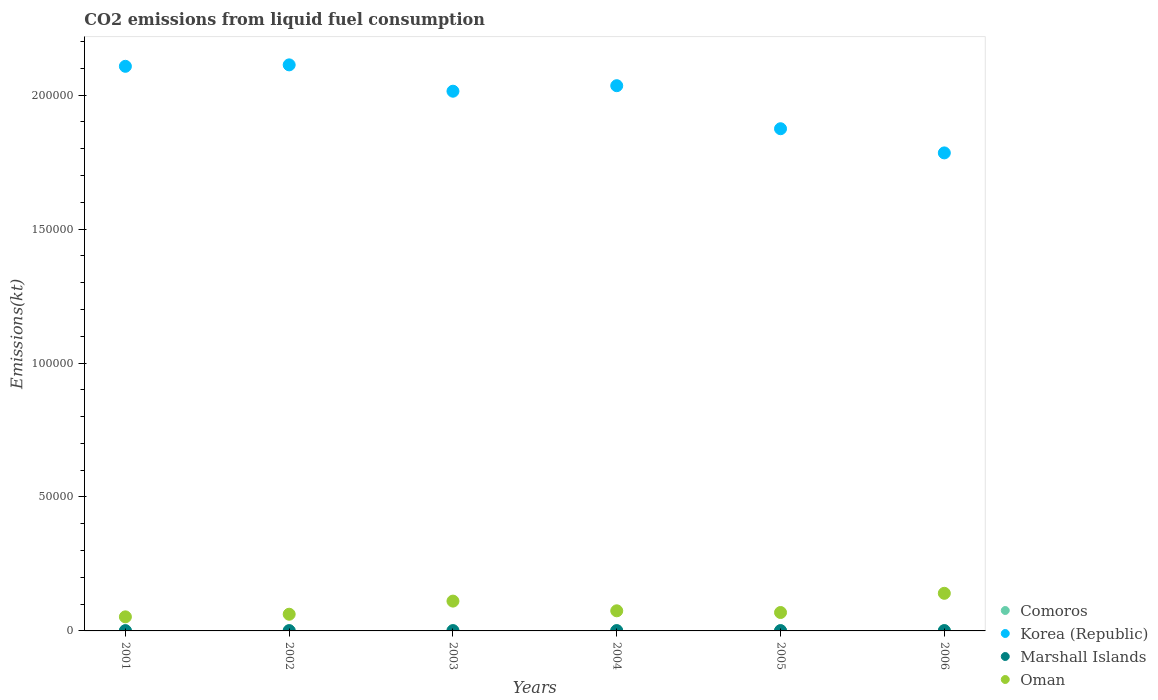How many different coloured dotlines are there?
Provide a short and direct response. 4. Is the number of dotlines equal to the number of legend labels?
Provide a succinct answer. Yes. What is the amount of CO2 emitted in Comoros in 2001?
Make the answer very short. 88.01. Across all years, what is the maximum amount of CO2 emitted in Korea (Republic)?
Your response must be concise. 2.11e+05. Across all years, what is the minimum amount of CO2 emitted in Oman?
Offer a terse response. 5254.81. In which year was the amount of CO2 emitted in Comoros minimum?
Make the answer very short. 2001. What is the total amount of CO2 emitted in Comoros in the graph?
Your response must be concise. 612.39. What is the difference between the amount of CO2 emitted in Comoros in 2002 and that in 2006?
Ensure brevity in your answer.  -29.34. What is the difference between the amount of CO2 emitted in Korea (Republic) in 2004 and the amount of CO2 emitted in Marshall Islands in 2001?
Ensure brevity in your answer.  2.03e+05. What is the average amount of CO2 emitted in Comoros per year?
Offer a terse response. 102.06. In the year 2004, what is the difference between the amount of CO2 emitted in Korea (Republic) and amount of CO2 emitted in Comoros?
Ensure brevity in your answer.  2.03e+05. What is the ratio of the amount of CO2 emitted in Oman in 2002 to that in 2006?
Your answer should be very brief. 0.44. Is the amount of CO2 emitted in Korea (Republic) in 2001 less than that in 2004?
Your answer should be compact. No. What is the difference between the highest and the second highest amount of CO2 emitted in Korea (Republic)?
Keep it short and to the point. 539.05. What is the difference between the highest and the lowest amount of CO2 emitted in Comoros?
Your answer should be compact. 33. In how many years, is the amount of CO2 emitted in Korea (Republic) greater than the average amount of CO2 emitted in Korea (Republic) taken over all years?
Provide a short and direct response. 4. Is it the case that in every year, the sum of the amount of CO2 emitted in Marshall Islands and amount of CO2 emitted in Korea (Republic)  is greater than the amount of CO2 emitted in Oman?
Your answer should be very brief. Yes. Does the amount of CO2 emitted in Korea (Republic) monotonically increase over the years?
Your response must be concise. No. Is the amount of CO2 emitted in Comoros strictly greater than the amount of CO2 emitted in Oman over the years?
Offer a terse response. No. How many dotlines are there?
Ensure brevity in your answer.  4. What is the title of the graph?
Offer a very short reply. CO2 emissions from liquid fuel consumption. Does "Swaziland" appear as one of the legend labels in the graph?
Provide a short and direct response. No. What is the label or title of the Y-axis?
Ensure brevity in your answer.  Emissions(kt). What is the Emissions(kt) of Comoros in 2001?
Offer a terse response. 88.01. What is the Emissions(kt) of Korea (Republic) in 2001?
Offer a very short reply. 2.11e+05. What is the Emissions(kt) of Marshall Islands in 2001?
Your answer should be compact. 80.67. What is the Emissions(kt) in Oman in 2001?
Your response must be concise. 5254.81. What is the Emissions(kt) in Comoros in 2002?
Your response must be concise. 91.67. What is the Emissions(kt) of Korea (Republic) in 2002?
Provide a succinct answer. 2.11e+05. What is the Emissions(kt) of Marshall Islands in 2002?
Your response must be concise. 84.34. What is the Emissions(kt) in Oman in 2002?
Ensure brevity in your answer.  6230.23. What is the Emissions(kt) in Comoros in 2003?
Provide a short and direct response. 99.01. What is the Emissions(kt) in Korea (Republic) in 2003?
Offer a very short reply. 2.01e+05. What is the Emissions(kt) in Marshall Islands in 2003?
Give a very brief answer. 84.34. What is the Emissions(kt) of Oman in 2003?
Ensure brevity in your answer.  1.11e+04. What is the Emissions(kt) of Comoros in 2004?
Make the answer very short. 102.68. What is the Emissions(kt) in Korea (Republic) in 2004?
Provide a short and direct response. 2.04e+05. What is the Emissions(kt) of Marshall Islands in 2004?
Make the answer very short. 88.01. What is the Emissions(kt) in Oman in 2004?
Keep it short and to the point. 7510.02. What is the Emissions(kt) of Comoros in 2005?
Provide a short and direct response. 110.01. What is the Emissions(kt) in Korea (Republic) in 2005?
Offer a terse response. 1.87e+05. What is the Emissions(kt) in Marshall Islands in 2005?
Offer a very short reply. 84.34. What is the Emissions(kt) in Oman in 2005?
Ensure brevity in your answer.  6875.62. What is the Emissions(kt) of Comoros in 2006?
Provide a short and direct response. 121.01. What is the Emissions(kt) of Korea (Republic) in 2006?
Make the answer very short. 1.78e+05. What is the Emissions(kt) in Marshall Islands in 2006?
Your answer should be very brief. 91.67. What is the Emissions(kt) of Oman in 2006?
Provide a succinct answer. 1.40e+04. Across all years, what is the maximum Emissions(kt) of Comoros?
Your response must be concise. 121.01. Across all years, what is the maximum Emissions(kt) of Korea (Republic)?
Your response must be concise. 2.11e+05. Across all years, what is the maximum Emissions(kt) of Marshall Islands?
Offer a terse response. 91.67. Across all years, what is the maximum Emissions(kt) in Oman?
Provide a succinct answer. 1.40e+04. Across all years, what is the minimum Emissions(kt) of Comoros?
Keep it short and to the point. 88.01. Across all years, what is the minimum Emissions(kt) in Korea (Republic)?
Offer a very short reply. 1.78e+05. Across all years, what is the minimum Emissions(kt) in Marshall Islands?
Your response must be concise. 80.67. Across all years, what is the minimum Emissions(kt) of Oman?
Offer a very short reply. 5254.81. What is the total Emissions(kt) of Comoros in the graph?
Offer a terse response. 612.39. What is the total Emissions(kt) in Korea (Republic) in the graph?
Provide a short and direct response. 1.19e+06. What is the total Emissions(kt) in Marshall Islands in the graph?
Offer a very short reply. 513.38. What is the total Emissions(kt) of Oman in the graph?
Provide a succinct answer. 5.10e+04. What is the difference between the Emissions(kt) in Comoros in 2001 and that in 2002?
Ensure brevity in your answer.  -3.67. What is the difference between the Emissions(kt) in Korea (Republic) in 2001 and that in 2002?
Offer a very short reply. -539.05. What is the difference between the Emissions(kt) in Marshall Islands in 2001 and that in 2002?
Give a very brief answer. -3.67. What is the difference between the Emissions(kt) in Oman in 2001 and that in 2002?
Keep it short and to the point. -975.42. What is the difference between the Emissions(kt) of Comoros in 2001 and that in 2003?
Provide a short and direct response. -11. What is the difference between the Emissions(kt) in Korea (Republic) in 2001 and that in 2003?
Your answer should be compact. 9295.84. What is the difference between the Emissions(kt) of Marshall Islands in 2001 and that in 2003?
Provide a short and direct response. -3.67. What is the difference between the Emissions(kt) of Oman in 2001 and that in 2003?
Your answer should be compact. -5874.53. What is the difference between the Emissions(kt) in Comoros in 2001 and that in 2004?
Offer a terse response. -14.67. What is the difference between the Emissions(kt) in Korea (Republic) in 2001 and that in 2004?
Your answer should be very brief. 7234.99. What is the difference between the Emissions(kt) in Marshall Islands in 2001 and that in 2004?
Your answer should be compact. -7.33. What is the difference between the Emissions(kt) of Oman in 2001 and that in 2004?
Your answer should be compact. -2255.2. What is the difference between the Emissions(kt) in Comoros in 2001 and that in 2005?
Ensure brevity in your answer.  -22. What is the difference between the Emissions(kt) in Korea (Republic) in 2001 and that in 2005?
Provide a short and direct response. 2.33e+04. What is the difference between the Emissions(kt) of Marshall Islands in 2001 and that in 2005?
Keep it short and to the point. -3.67. What is the difference between the Emissions(kt) of Oman in 2001 and that in 2005?
Your answer should be very brief. -1620.81. What is the difference between the Emissions(kt) of Comoros in 2001 and that in 2006?
Ensure brevity in your answer.  -33. What is the difference between the Emissions(kt) of Korea (Republic) in 2001 and that in 2006?
Your response must be concise. 3.23e+04. What is the difference between the Emissions(kt) of Marshall Islands in 2001 and that in 2006?
Provide a succinct answer. -11. What is the difference between the Emissions(kt) of Oman in 2001 and that in 2006?
Ensure brevity in your answer.  -8786.13. What is the difference between the Emissions(kt) of Comoros in 2002 and that in 2003?
Your answer should be very brief. -7.33. What is the difference between the Emissions(kt) in Korea (Republic) in 2002 and that in 2003?
Your response must be concise. 9834.89. What is the difference between the Emissions(kt) of Marshall Islands in 2002 and that in 2003?
Offer a terse response. 0. What is the difference between the Emissions(kt) of Oman in 2002 and that in 2003?
Keep it short and to the point. -4899.11. What is the difference between the Emissions(kt) of Comoros in 2002 and that in 2004?
Your answer should be very brief. -11. What is the difference between the Emissions(kt) in Korea (Republic) in 2002 and that in 2004?
Ensure brevity in your answer.  7774.04. What is the difference between the Emissions(kt) of Marshall Islands in 2002 and that in 2004?
Keep it short and to the point. -3.67. What is the difference between the Emissions(kt) of Oman in 2002 and that in 2004?
Make the answer very short. -1279.78. What is the difference between the Emissions(kt) in Comoros in 2002 and that in 2005?
Provide a succinct answer. -18.34. What is the difference between the Emissions(kt) in Korea (Republic) in 2002 and that in 2005?
Your answer should be very brief. 2.38e+04. What is the difference between the Emissions(kt) of Oman in 2002 and that in 2005?
Your answer should be very brief. -645.39. What is the difference between the Emissions(kt) in Comoros in 2002 and that in 2006?
Your answer should be very brief. -29.34. What is the difference between the Emissions(kt) of Korea (Republic) in 2002 and that in 2006?
Your answer should be very brief. 3.29e+04. What is the difference between the Emissions(kt) of Marshall Islands in 2002 and that in 2006?
Your answer should be compact. -7.33. What is the difference between the Emissions(kt) in Oman in 2002 and that in 2006?
Provide a short and direct response. -7810.71. What is the difference between the Emissions(kt) of Comoros in 2003 and that in 2004?
Keep it short and to the point. -3.67. What is the difference between the Emissions(kt) in Korea (Republic) in 2003 and that in 2004?
Offer a terse response. -2060.85. What is the difference between the Emissions(kt) in Marshall Islands in 2003 and that in 2004?
Ensure brevity in your answer.  -3.67. What is the difference between the Emissions(kt) in Oman in 2003 and that in 2004?
Provide a short and direct response. 3619.33. What is the difference between the Emissions(kt) in Comoros in 2003 and that in 2005?
Make the answer very short. -11. What is the difference between the Emissions(kt) of Korea (Republic) in 2003 and that in 2005?
Give a very brief answer. 1.40e+04. What is the difference between the Emissions(kt) in Oman in 2003 and that in 2005?
Ensure brevity in your answer.  4253.72. What is the difference between the Emissions(kt) in Comoros in 2003 and that in 2006?
Provide a short and direct response. -22. What is the difference between the Emissions(kt) of Korea (Republic) in 2003 and that in 2006?
Provide a succinct answer. 2.30e+04. What is the difference between the Emissions(kt) of Marshall Islands in 2003 and that in 2006?
Ensure brevity in your answer.  -7.33. What is the difference between the Emissions(kt) of Oman in 2003 and that in 2006?
Keep it short and to the point. -2911.6. What is the difference between the Emissions(kt) of Comoros in 2004 and that in 2005?
Provide a short and direct response. -7.33. What is the difference between the Emissions(kt) of Korea (Republic) in 2004 and that in 2005?
Your answer should be very brief. 1.61e+04. What is the difference between the Emissions(kt) of Marshall Islands in 2004 and that in 2005?
Provide a short and direct response. 3.67. What is the difference between the Emissions(kt) of Oman in 2004 and that in 2005?
Make the answer very short. 634.39. What is the difference between the Emissions(kt) of Comoros in 2004 and that in 2006?
Provide a short and direct response. -18.34. What is the difference between the Emissions(kt) of Korea (Republic) in 2004 and that in 2006?
Make the answer very short. 2.51e+04. What is the difference between the Emissions(kt) of Marshall Islands in 2004 and that in 2006?
Keep it short and to the point. -3.67. What is the difference between the Emissions(kt) of Oman in 2004 and that in 2006?
Your response must be concise. -6530.93. What is the difference between the Emissions(kt) of Comoros in 2005 and that in 2006?
Offer a very short reply. -11. What is the difference between the Emissions(kt) in Korea (Republic) in 2005 and that in 2006?
Your answer should be very brief. 9024.49. What is the difference between the Emissions(kt) in Marshall Islands in 2005 and that in 2006?
Offer a terse response. -7.33. What is the difference between the Emissions(kt) in Oman in 2005 and that in 2006?
Offer a terse response. -7165.32. What is the difference between the Emissions(kt) in Comoros in 2001 and the Emissions(kt) in Korea (Republic) in 2002?
Your response must be concise. -2.11e+05. What is the difference between the Emissions(kt) in Comoros in 2001 and the Emissions(kt) in Marshall Islands in 2002?
Offer a terse response. 3.67. What is the difference between the Emissions(kt) of Comoros in 2001 and the Emissions(kt) of Oman in 2002?
Keep it short and to the point. -6142.23. What is the difference between the Emissions(kt) in Korea (Republic) in 2001 and the Emissions(kt) in Marshall Islands in 2002?
Make the answer very short. 2.11e+05. What is the difference between the Emissions(kt) in Korea (Republic) in 2001 and the Emissions(kt) in Oman in 2002?
Make the answer very short. 2.05e+05. What is the difference between the Emissions(kt) in Marshall Islands in 2001 and the Emissions(kt) in Oman in 2002?
Provide a succinct answer. -6149.56. What is the difference between the Emissions(kt) in Comoros in 2001 and the Emissions(kt) in Korea (Republic) in 2003?
Your answer should be compact. -2.01e+05. What is the difference between the Emissions(kt) in Comoros in 2001 and the Emissions(kt) in Marshall Islands in 2003?
Your response must be concise. 3.67. What is the difference between the Emissions(kt) of Comoros in 2001 and the Emissions(kt) of Oman in 2003?
Keep it short and to the point. -1.10e+04. What is the difference between the Emissions(kt) of Korea (Republic) in 2001 and the Emissions(kt) of Marshall Islands in 2003?
Provide a succinct answer. 2.11e+05. What is the difference between the Emissions(kt) in Korea (Republic) in 2001 and the Emissions(kt) in Oman in 2003?
Offer a terse response. 2.00e+05. What is the difference between the Emissions(kt) of Marshall Islands in 2001 and the Emissions(kt) of Oman in 2003?
Keep it short and to the point. -1.10e+04. What is the difference between the Emissions(kt) in Comoros in 2001 and the Emissions(kt) in Korea (Republic) in 2004?
Provide a succinct answer. -2.03e+05. What is the difference between the Emissions(kt) in Comoros in 2001 and the Emissions(kt) in Oman in 2004?
Keep it short and to the point. -7422.01. What is the difference between the Emissions(kt) in Korea (Republic) in 2001 and the Emissions(kt) in Marshall Islands in 2004?
Your answer should be compact. 2.11e+05. What is the difference between the Emissions(kt) of Korea (Republic) in 2001 and the Emissions(kt) of Oman in 2004?
Offer a very short reply. 2.03e+05. What is the difference between the Emissions(kt) in Marshall Islands in 2001 and the Emissions(kt) in Oman in 2004?
Provide a short and direct response. -7429.34. What is the difference between the Emissions(kt) of Comoros in 2001 and the Emissions(kt) of Korea (Republic) in 2005?
Provide a succinct answer. -1.87e+05. What is the difference between the Emissions(kt) in Comoros in 2001 and the Emissions(kt) in Marshall Islands in 2005?
Your response must be concise. 3.67. What is the difference between the Emissions(kt) in Comoros in 2001 and the Emissions(kt) in Oman in 2005?
Ensure brevity in your answer.  -6787.62. What is the difference between the Emissions(kt) of Korea (Republic) in 2001 and the Emissions(kt) of Marshall Islands in 2005?
Your response must be concise. 2.11e+05. What is the difference between the Emissions(kt) in Korea (Republic) in 2001 and the Emissions(kt) in Oman in 2005?
Make the answer very short. 2.04e+05. What is the difference between the Emissions(kt) in Marshall Islands in 2001 and the Emissions(kt) in Oman in 2005?
Your response must be concise. -6794.95. What is the difference between the Emissions(kt) in Comoros in 2001 and the Emissions(kt) in Korea (Republic) in 2006?
Your answer should be very brief. -1.78e+05. What is the difference between the Emissions(kt) in Comoros in 2001 and the Emissions(kt) in Marshall Islands in 2006?
Provide a succinct answer. -3.67. What is the difference between the Emissions(kt) in Comoros in 2001 and the Emissions(kt) in Oman in 2006?
Ensure brevity in your answer.  -1.40e+04. What is the difference between the Emissions(kt) in Korea (Republic) in 2001 and the Emissions(kt) in Marshall Islands in 2006?
Provide a succinct answer. 2.11e+05. What is the difference between the Emissions(kt) in Korea (Republic) in 2001 and the Emissions(kt) in Oman in 2006?
Your response must be concise. 1.97e+05. What is the difference between the Emissions(kt) of Marshall Islands in 2001 and the Emissions(kt) of Oman in 2006?
Offer a very short reply. -1.40e+04. What is the difference between the Emissions(kt) in Comoros in 2002 and the Emissions(kt) in Korea (Republic) in 2003?
Offer a terse response. -2.01e+05. What is the difference between the Emissions(kt) of Comoros in 2002 and the Emissions(kt) of Marshall Islands in 2003?
Provide a succinct answer. 7.33. What is the difference between the Emissions(kt) of Comoros in 2002 and the Emissions(kt) of Oman in 2003?
Your answer should be very brief. -1.10e+04. What is the difference between the Emissions(kt) of Korea (Republic) in 2002 and the Emissions(kt) of Marshall Islands in 2003?
Provide a succinct answer. 2.11e+05. What is the difference between the Emissions(kt) in Korea (Republic) in 2002 and the Emissions(kt) in Oman in 2003?
Make the answer very short. 2.00e+05. What is the difference between the Emissions(kt) in Marshall Islands in 2002 and the Emissions(kt) in Oman in 2003?
Give a very brief answer. -1.10e+04. What is the difference between the Emissions(kt) in Comoros in 2002 and the Emissions(kt) in Korea (Republic) in 2004?
Give a very brief answer. -2.03e+05. What is the difference between the Emissions(kt) in Comoros in 2002 and the Emissions(kt) in Marshall Islands in 2004?
Your answer should be compact. 3.67. What is the difference between the Emissions(kt) in Comoros in 2002 and the Emissions(kt) in Oman in 2004?
Your answer should be very brief. -7418.34. What is the difference between the Emissions(kt) in Korea (Republic) in 2002 and the Emissions(kt) in Marshall Islands in 2004?
Offer a terse response. 2.11e+05. What is the difference between the Emissions(kt) of Korea (Republic) in 2002 and the Emissions(kt) of Oman in 2004?
Make the answer very short. 2.04e+05. What is the difference between the Emissions(kt) of Marshall Islands in 2002 and the Emissions(kt) of Oman in 2004?
Provide a short and direct response. -7425.68. What is the difference between the Emissions(kt) of Comoros in 2002 and the Emissions(kt) of Korea (Republic) in 2005?
Give a very brief answer. -1.87e+05. What is the difference between the Emissions(kt) of Comoros in 2002 and the Emissions(kt) of Marshall Islands in 2005?
Your answer should be very brief. 7.33. What is the difference between the Emissions(kt) of Comoros in 2002 and the Emissions(kt) of Oman in 2005?
Offer a terse response. -6783.95. What is the difference between the Emissions(kt) of Korea (Republic) in 2002 and the Emissions(kt) of Marshall Islands in 2005?
Provide a short and direct response. 2.11e+05. What is the difference between the Emissions(kt) in Korea (Republic) in 2002 and the Emissions(kt) in Oman in 2005?
Ensure brevity in your answer.  2.04e+05. What is the difference between the Emissions(kt) in Marshall Islands in 2002 and the Emissions(kt) in Oman in 2005?
Keep it short and to the point. -6791.28. What is the difference between the Emissions(kt) in Comoros in 2002 and the Emissions(kt) in Korea (Republic) in 2006?
Your answer should be compact. -1.78e+05. What is the difference between the Emissions(kt) in Comoros in 2002 and the Emissions(kt) in Marshall Islands in 2006?
Provide a succinct answer. 0. What is the difference between the Emissions(kt) in Comoros in 2002 and the Emissions(kt) in Oman in 2006?
Offer a very short reply. -1.39e+04. What is the difference between the Emissions(kt) in Korea (Republic) in 2002 and the Emissions(kt) in Marshall Islands in 2006?
Your answer should be compact. 2.11e+05. What is the difference between the Emissions(kt) of Korea (Republic) in 2002 and the Emissions(kt) of Oman in 2006?
Offer a terse response. 1.97e+05. What is the difference between the Emissions(kt) of Marshall Islands in 2002 and the Emissions(kt) of Oman in 2006?
Make the answer very short. -1.40e+04. What is the difference between the Emissions(kt) of Comoros in 2003 and the Emissions(kt) of Korea (Republic) in 2004?
Make the answer very short. -2.03e+05. What is the difference between the Emissions(kt) in Comoros in 2003 and the Emissions(kt) in Marshall Islands in 2004?
Offer a terse response. 11. What is the difference between the Emissions(kt) in Comoros in 2003 and the Emissions(kt) in Oman in 2004?
Your answer should be very brief. -7411.01. What is the difference between the Emissions(kt) in Korea (Republic) in 2003 and the Emissions(kt) in Marshall Islands in 2004?
Offer a terse response. 2.01e+05. What is the difference between the Emissions(kt) in Korea (Republic) in 2003 and the Emissions(kt) in Oman in 2004?
Offer a very short reply. 1.94e+05. What is the difference between the Emissions(kt) of Marshall Islands in 2003 and the Emissions(kt) of Oman in 2004?
Keep it short and to the point. -7425.68. What is the difference between the Emissions(kt) in Comoros in 2003 and the Emissions(kt) in Korea (Republic) in 2005?
Keep it short and to the point. -1.87e+05. What is the difference between the Emissions(kt) of Comoros in 2003 and the Emissions(kt) of Marshall Islands in 2005?
Provide a short and direct response. 14.67. What is the difference between the Emissions(kt) of Comoros in 2003 and the Emissions(kt) of Oman in 2005?
Offer a very short reply. -6776.62. What is the difference between the Emissions(kt) in Korea (Republic) in 2003 and the Emissions(kt) in Marshall Islands in 2005?
Provide a succinct answer. 2.01e+05. What is the difference between the Emissions(kt) of Korea (Republic) in 2003 and the Emissions(kt) of Oman in 2005?
Your response must be concise. 1.95e+05. What is the difference between the Emissions(kt) of Marshall Islands in 2003 and the Emissions(kt) of Oman in 2005?
Your answer should be very brief. -6791.28. What is the difference between the Emissions(kt) of Comoros in 2003 and the Emissions(kt) of Korea (Republic) in 2006?
Provide a succinct answer. -1.78e+05. What is the difference between the Emissions(kt) of Comoros in 2003 and the Emissions(kt) of Marshall Islands in 2006?
Provide a short and direct response. 7.33. What is the difference between the Emissions(kt) in Comoros in 2003 and the Emissions(kt) in Oman in 2006?
Your response must be concise. -1.39e+04. What is the difference between the Emissions(kt) of Korea (Republic) in 2003 and the Emissions(kt) of Marshall Islands in 2006?
Ensure brevity in your answer.  2.01e+05. What is the difference between the Emissions(kt) in Korea (Republic) in 2003 and the Emissions(kt) in Oman in 2006?
Give a very brief answer. 1.87e+05. What is the difference between the Emissions(kt) of Marshall Islands in 2003 and the Emissions(kt) of Oman in 2006?
Ensure brevity in your answer.  -1.40e+04. What is the difference between the Emissions(kt) of Comoros in 2004 and the Emissions(kt) of Korea (Republic) in 2005?
Ensure brevity in your answer.  -1.87e+05. What is the difference between the Emissions(kt) in Comoros in 2004 and the Emissions(kt) in Marshall Islands in 2005?
Ensure brevity in your answer.  18.34. What is the difference between the Emissions(kt) in Comoros in 2004 and the Emissions(kt) in Oman in 2005?
Provide a succinct answer. -6772.95. What is the difference between the Emissions(kt) of Korea (Republic) in 2004 and the Emissions(kt) of Marshall Islands in 2005?
Your answer should be very brief. 2.03e+05. What is the difference between the Emissions(kt) in Korea (Republic) in 2004 and the Emissions(kt) in Oman in 2005?
Provide a succinct answer. 1.97e+05. What is the difference between the Emissions(kt) of Marshall Islands in 2004 and the Emissions(kt) of Oman in 2005?
Make the answer very short. -6787.62. What is the difference between the Emissions(kt) of Comoros in 2004 and the Emissions(kt) of Korea (Republic) in 2006?
Provide a succinct answer. -1.78e+05. What is the difference between the Emissions(kt) of Comoros in 2004 and the Emissions(kt) of Marshall Islands in 2006?
Provide a succinct answer. 11. What is the difference between the Emissions(kt) of Comoros in 2004 and the Emissions(kt) of Oman in 2006?
Your answer should be very brief. -1.39e+04. What is the difference between the Emissions(kt) of Korea (Republic) in 2004 and the Emissions(kt) of Marshall Islands in 2006?
Offer a very short reply. 2.03e+05. What is the difference between the Emissions(kt) in Korea (Republic) in 2004 and the Emissions(kt) in Oman in 2006?
Make the answer very short. 1.90e+05. What is the difference between the Emissions(kt) of Marshall Islands in 2004 and the Emissions(kt) of Oman in 2006?
Offer a terse response. -1.40e+04. What is the difference between the Emissions(kt) in Comoros in 2005 and the Emissions(kt) in Korea (Republic) in 2006?
Offer a very short reply. -1.78e+05. What is the difference between the Emissions(kt) of Comoros in 2005 and the Emissions(kt) of Marshall Islands in 2006?
Offer a very short reply. 18.34. What is the difference between the Emissions(kt) of Comoros in 2005 and the Emissions(kt) of Oman in 2006?
Provide a short and direct response. -1.39e+04. What is the difference between the Emissions(kt) of Korea (Republic) in 2005 and the Emissions(kt) of Marshall Islands in 2006?
Provide a short and direct response. 1.87e+05. What is the difference between the Emissions(kt) of Korea (Republic) in 2005 and the Emissions(kt) of Oman in 2006?
Offer a very short reply. 1.73e+05. What is the difference between the Emissions(kt) in Marshall Islands in 2005 and the Emissions(kt) in Oman in 2006?
Ensure brevity in your answer.  -1.40e+04. What is the average Emissions(kt) in Comoros per year?
Give a very brief answer. 102.06. What is the average Emissions(kt) in Korea (Republic) per year?
Give a very brief answer. 1.99e+05. What is the average Emissions(kt) of Marshall Islands per year?
Your answer should be compact. 85.56. What is the average Emissions(kt) in Oman per year?
Your answer should be compact. 8506.83. In the year 2001, what is the difference between the Emissions(kt) of Comoros and Emissions(kt) of Korea (Republic)?
Your response must be concise. -2.11e+05. In the year 2001, what is the difference between the Emissions(kt) of Comoros and Emissions(kt) of Marshall Islands?
Provide a succinct answer. 7.33. In the year 2001, what is the difference between the Emissions(kt) in Comoros and Emissions(kt) in Oman?
Keep it short and to the point. -5166.8. In the year 2001, what is the difference between the Emissions(kt) in Korea (Republic) and Emissions(kt) in Marshall Islands?
Provide a succinct answer. 2.11e+05. In the year 2001, what is the difference between the Emissions(kt) in Korea (Republic) and Emissions(kt) in Oman?
Your answer should be compact. 2.06e+05. In the year 2001, what is the difference between the Emissions(kt) in Marshall Islands and Emissions(kt) in Oman?
Your answer should be compact. -5174.14. In the year 2002, what is the difference between the Emissions(kt) in Comoros and Emissions(kt) in Korea (Republic)?
Keep it short and to the point. -2.11e+05. In the year 2002, what is the difference between the Emissions(kt) in Comoros and Emissions(kt) in Marshall Islands?
Your answer should be very brief. 7.33. In the year 2002, what is the difference between the Emissions(kt) in Comoros and Emissions(kt) in Oman?
Offer a very short reply. -6138.56. In the year 2002, what is the difference between the Emissions(kt) in Korea (Republic) and Emissions(kt) in Marshall Islands?
Ensure brevity in your answer.  2.11e+05. In the year 2002, what is the difference between the Emissions(kt) of Korea (Republic) and Emissions(kt) of Oman?
Ensure brevity in your answer.  2.05e+05. In the year 2002, what is the difference between the Emissions(kt) of Marshall Islands and Emissions(kt) of Oman?
Offer a very short reply. -6145.89. In the year 2003, what is the difference between the Emissions(kt) of Comoros and Emissions(kt) of Korea (Republic)?
Provide a short and direct response. -2.01e+05. In the year 2003, what is the difference between the Emissions(kt) of Comoros and Emissions(kt) of Marshall Islands?
Ensure brevity in your answer.  14.67. In the year 2003, what is the difference between the Emissions(kt) of Comoros and Emissions(kt) of Oman?
Your answer should be compact. -1.10e+04. In the year 2003, what is the difference between the Emissions(kt) in Korea (Republic) and Emissions(kt) in Marshall Islands?
Offer a very short reply. 2.01e+05. In the year 2003, what is the difference between the Emissions(kt) of Korea (Republic) and Emissions(kt) of Oman?
Offer a very short reply. 1.90e+05. In the year 2003, what is the difference between the Emissions(kt) in Marshall Islands and Emissions(kt) in Oman?
Make the answer very short. -1.10e+04. In the year 2004, what is the difference between the Emissions(kt) in Comoros and Emissions(kt) in Korea (Republic)?
Keep it short and to the point. -2.03e+05. In the year 2004, what is the difference between the Emissions(kt) in Comoros and Emissions(kt) in Marshall Islands?
Give a very brief answer. 14.67. In the year 2004, what is the difference between the Emissions(kt) in Comoros and Emissions(kt) in Oman?
Make the answer very short. -7407.34. In the year 2004, what is the difference between the Emissions(kt) of Korea (Republic) and Emissions(kt) of Marshall Islands?
Keep it short and to the point. 2.03e+05. In the year 2004, what is the difference between the Emissions(kt) in Korea (Republic) and Emissions(kt) in Oman?
Ensure brevity in your answer.  1.96e+05. In the year 2004, what is the difference between the Emissions(kt) of Marshall Islands and Emissions(kt) of Oman?
Offer a very short reply. -7422.01. In the year 2005, what is the difference between the Emissions(kt) of Comoros and Emissions(kt) of Korea (Republic)?
Make the answer very short. -1.87e+05. In the year 2005, what is the difference between the Emissions(kt) in Comoros and Emissions(kt) in Marshall Islands?
Provide a short and direct response. 25.67. In the year 2005, what is the difference between the Emissions(kt) in Comoros and Emissions(kt) in Oman?
Offer a terse response. -6765.61. In the year 2005, what is the difference between the Emissions(kt) of Korea (Republic) and Emissions(kt) of Marshall Islands?
Offer a terse response. 1.87e+05. In the year 2005, what is the difference between the Emissions(kt) of Korea (Republic) and Emissions(kt) of Oman?
Your response must be concise. 1.81e+05. In the year 2005, what is the difference between the Emissions(kt) in Marshall Islands and Emissions(kt) in Oman?
Your answer should be very brief. -6791.28. In the year 2006, what is the difference between the Emissions(kt) of Comoros and Emissions(kt) of Korea (Republic)?
Your response must be concise. -1.78e+05. In the year 2006, what is the difference between the Emissions(kt) of Comoros and Emissions(kt) of Marshall Islands?
Ensure brevity in your answer.  29.34. In the year 2006, what is the difference between the Emissions(kt) in Comoros and Emissions(kt) in Oman?
Your answer should be very brief. -1.39e+04. In the year 2006, what is the difference between the Emissions(kt) of Korea (Republic) and Emissions(kt) of Marshall Islands?
Keep it short and to the point. 1.78e+05. In the year 2006, what is the difference between the Emissions(kt) of Korea (Republic) and Emissions(kt) of Oman?
Offer a terse response. 1.64e+05. In the year 2006, what is the difference between the Emissions(kt) in Marshall Islands and Emissions(kt) in Oman?
Give a very brief answer. -1.39e+04. What is the ratio of the Emissions(kt) of Comoros in 2001 to that in 2002?
Your response must be concise. 0.96. What is the ratio of the Emissions(kt) in Marshall Islands in 2001 to that in 2002?
Your answer should be very brief. 0.96. What is the ratio of the Emissions(kt) in Oman in 2001 to that in 2002?
Your answer should be compact. 0.84. What is the ratio of the Emissions(kt) in Korea (Republic) in 2001 to that in 2003?
Offer a very short reply. 1.05. What is the ratio of the Emissions(kt) in Marshall Islands in 2001 to that in 2003?
Offer a terse response. 0.96. What is the ratio of the Emissions(kt) in Oman in 2001 to that in 2003?
Provide a succinct answer. 0.47. What is the ratio of the Emissions(kt) of Korea (Republic) in 2001 to that in 2004?
Make the answer very short. 1.04. What is the ratio of the Emissions(kt) of Marshall Islands in 2001 to that in 2004?
Make the answer very short. 0.92. What is the ratio of the Emissions(kt) in Oman in 2001 to that in 2004?
Provide a succinct answer. 0.7. What is the ratio of the Emissions(kt) in Korea (Republic) in 2001 to that in 2005?
Ensure brevity in your answer.  1.12. What is the ratio of the Emissions(kt) in Marshall Islands in 2001 to that in 2005?
Give a very brief answer. 0.96. What is the ratio of the Emissions(kt) of Oman in 2001 to that in 2005?
Ensure brevity in your answer.  0.76. What is the ratio of the Emissions(kt) in Comoros in 2001 to that in 2006?
Provide a short and direct response. 0.73. What is the ratio of the Emissions(kt) of Korea (Republic) in 2001 to that in 2006?
Your answer should be very brief. 1.18. What is the ratio of the Emissions(kt) of Marshall Islands in 2001 to that in 2006?
Make the answer very short. 0.88. What is the ratio of the Emissions(kt) of Oman in 2001 to that in 2006?
Give a very brief answer. 0.37. What is the ratio of the Emissions(kt) in Comoros in 2002 to that in 2003?
Offer a terse response. 0.93. What is the ratio of the Emissions(kt) in Korea (Republic) in 2002 to that in 2003?
Your answer should be very brief. 1.05. What is the ratio of the Emissions(kt) in Oman in 2002 to that in 2003?
Make the answer very short. 0.56. What is the ratio of the Emissions(kt) in Comoros in 2002 to that in 2004?
Your answer should be compact. 0.89. What is the ratio of the Emissions(kt) in Korea (Republic) in 2002 to that in 2004?
Make the answer very short. 1.04. What is the ratio of the Emissions(kt) of Oman in 2002 to that in 2004?
Ensure brevity in your answer.  0.83. What is the ratio of the Emissions(kt) in Korea (Republic) in 2002 to that in 2005?
Offer a very short reply. 1.13. What is the ratio of the Emissions(kt) in Marshall Islands in 2002 to that in 2005?
Your response must be concise. 1. What is the ratio of the Emissions(kt) in Oman in 2002 to that in 2005?
Provide a short and direct response. 0.91. What is the ratio of the Emissions(kt) in Comoros in 2002 to that in 2006?
Your answer should be compact. 0.76. What is the ratio of the Emissions(kt) of Korea (Republic) in 2002 to that in 2006?
Make the answer very short. 1.18. What is the ratio of the Emissions(kt) of Marshall Islands in 2002 to that in 2006?
Your answer should be compact. 0.92. What is the ratio of the Emissions(kt) in Oman in 2002 to that in 2006?
Offer a terse response. 0.44. What is the ratio of the Emissions(kt) in Comoros in 2003 to that in 2004?
Provide a succinct answer. 0.96. What is the ratio of the Emissions(kt) in Korea (Republic) in 2003 to that in 2004?
Provide a succinct answer. 0.99. What is the ratio of the Emissions(kt) of Oman in 2003 to that in 2004?
Your response must be concise. 1.48. What is the ratio of the Emissions(kt) of Korea (Republic) in 2003 to that in 2005?
Keep it short and to the point. 1.07. What is the ratio of the Emissions(kt) of Marshall Islands in 2003 to that in 2005?
Provide a succinct answer. 1. What is the ratio of the Emissions(kt) in Oman in 2003 to that in 2005?
Offer a very short reply. 1.62. What is the ratio of the Emissions(kt) of Comoros in 2003 to that in 2006?
Your answer should be very brief. 0.82. What is the ratio of the Emissions(kt) of Korea (Republic) in 2003 to that in 2006?
Offer a very short reply. 1.13. What is the ratio of the Emissions(kt) in Marshall Islands in 2003 to that in 2006?
Your response must be concise. 0.92. What is the ratio of the Emissions(kt) of Oman in 2003 to that in 2006?
Your response must be concise. 0.79. What is the ratio of the Emissions(kt) in Comoros in 2004 to that in 2005?
Offer a terse response. 0.93. What is the ratio of the Emissions(kt) of Korea (Republic) in 2004 to that in 2005?
Provide a short and direct response. 1.09. What is the ratio of the Emissions(kt) of Marshall Islands in 2004 to that in 2005?
Offer a very short reply. 1.04. What is the ratio of the Emissions(kt) in Oman in 2004 to that in 2005?
Provide a short and direct response. 1.09. What is the ratio of the Emissions(kt) in Comoros in 2004 to that in 2006?
Ensure brevity in your answer.  0.85. What is the ratio of the Emissions(kt) of Korea (Republic) in 2004 to that in 2006?
Provide a succinct answer. 1.14. What is the ratio of the Emissions(kt) of Oman in 2004 to that in 2006?
Keep it short and to the point. 0.53. What is the ratio of the Emissions(kt) in Comoros in 2005 to that in 2006?
Give a very brief answer. 0.91. What is the ratio of the Emissions(kt) of Korea (Republic) in 2005 to that in 2006?
Provide a short and direct response. 1.05. What is the ratio of the Emissions(kt) in Marshall Islands in 2005 to that in 2006?
Provide a short and direct response. 0.92. What is the ratio of the Emissions(kt) of Oman in 2005 to that in 2006?
Provide a short and direct response. 0.49. What is the difference between the highest and the second highest Emissions(kt) in Comoros?
Provide a short and direct response. 11. What is the difference between the highest and the second highest Emissions(kt) in Korea (Republic)?
Offer a very short reply. 539.05. What is the difference between the highest and the second highest Emissions(kt) in Marshall Islands?
Provide a short and direct response. 3.67. What is the difference between the highest and the second highest Emissions(kt) of Oman?
Make the answer very short. 2911.6. What is the difference between the highest and the lowest Emissions(kt) in Comoros?
Your response must be concise. 33. What is the difference between the highest and the lowest Emissions(kt) in Korea (Republic)?
Provide a succinct answer. 3.29e+04. What is the difference between the highest and the lowest Emissions(kt) in Marshall Islands?
Provide a short and direct response. 11. What is the difference between the highest and the lowest Emissions(kt) of Oman?
Ensure brevity in your answer.  8786.13. 